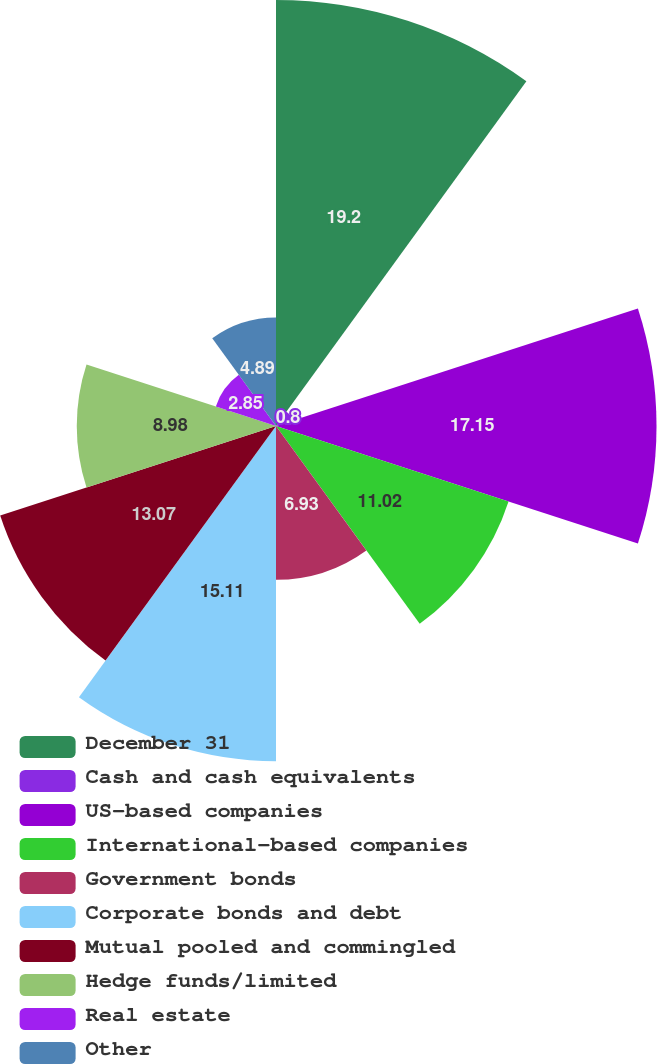Convert chart to OTSL. <chart><loc_0><loc_0><loc_500><loc_500><pie_chart><fcel>December 31<fcel>Cash and cash equivalents<fcel>US-based companies<fcel>International-based companies<fcel>Government bonds<fcel>Corporate bonds and debt<fcel>Mutual pooled and commingled<fcel>Hedge funds/limited<fcel>Real estate<fcel>Other<nl><fcel>19.2%<fcel>0.8%<fcel>17.15%<fcel>11.02%<fcel>6.93%<fcel>15.11%<fcel>13.07%<fcel>8.98%<fcel>2.85%<fcel>4.89%<nl></chart> 